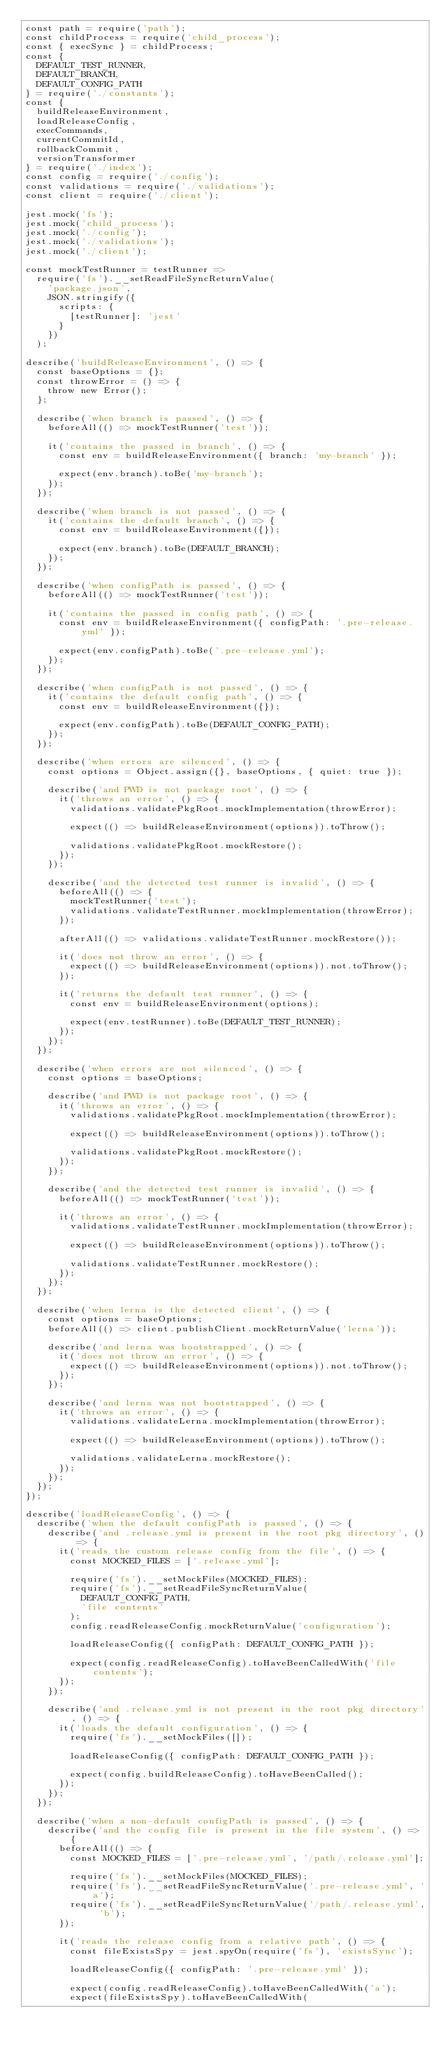<code> <loc_0><loc_0><loc_500><loc_500><_JavaScript_>const path = require('path');
const childProcess = require('child_process');
const { execSync } = childProcess;
const {
  DEFAULT_TEST_RUNNER,
  DEFAULT_BRANCH,
  DEFAULT_CONFIG_PATH
} = require('./constants');
const {
  buildReleaseEnvironment,
  loadReleaseConfig,
  execCommands,
  currentCommitId,
  rollbackCommit,
  versionTransformer
} = require('./index');
const config = require('./config');
const validations = require('./validations');
const client = require('./client');

jest.mock('fs');
jest.mock('child_process');
jest.mock('./config');
jest.mock('./validations');
jest.mock('./client');

const mockTestRunner = testRunner =>
  require('fs').__setReadFileSyncReturnValue(
    'package.json',
    JSON.stringify({
      scripts: {
        [testRunner]: 'jest'
      }
    })
  );

describe('buildReleaseEnvironment', () => {
  const baseOptions = {};
  const throwError = () => {
    throw new Error();
  };

  describe('when branch is passed', () => {
    beforeAll(() => mockTestRunner('test'));

    it('contains the passed in branch', () => {
      const env = buildReleaseEnvironment({ branch: 'my-branch' });

      expect(env.branch).toBe('my-branch');
    });
  });

  describe('when branch is not passed', () => {
    it('contains the default branch', () => {
      const env = buildReleaseEnvironment({});

      expect(env.branch).toBe(DEFAULT_BRANCH);
    });
  });

  describe('when configPath is passed', () => {
    beforeAll(() => mockTestRunner('test'));

    it('contains the passed in config path', () => {
      const env = buildReleaseEnvironment({ configPath: '.pre-release.yml' });

      expect(env.configPath).toBe('.pre-release.yml');
    });
  });

  describe('when configPath is not passed', () => {
    it('contains the default config path', () => {
      const env = buildReleaseEnvironment({});

      expect(env.configPath).toBe(DEFAULT_CONFIG_PATH);
    });
  });

  describe('when errors are silenced', () => {
    const options = Object.assign({}, baseOptions, { quiet: true });

    describe('and PWD is not package root', () => {
      it('throws an error', () => {
        validations.validatePkgRoot.mockImplementation(throwError);

        expect(() => buildReleaseEnvironment(options)).toThrow();

        validations.validatePkgRoot.mockRestore();
      });
    });

    describe('and the detected test runner is invalid', () => {
      beforeAll(() => {
        mockTestRunner('test');
        validations.validateTestRunner.mockImplementation(throwError);
      });

      afterAll(() => validations.validateTestRunner.mockRestore());

      it('does not throw an error', () => {
        expect(() => buildReleaseEnvironment(options)).not.toThrow();
      });

      it('returns the default test runner', () => {
        const env = buildReleaseEnvironment(options);

        expect(env.testRunner).toBe(DEFAULT_TEST_RUNNER);
      });
    });
  });

  describe('when errors are not silenced', () => {
    const options = baseOptions;

    describe('and PWD is not package root', () => {
      it('throws an error', () => {
        validations.validatePkgRoot.mockImplementation(throwError);

        expect(() => buildReleaseEnvironment(options)).toThrow();

        validations.validatePkgRoot.mockRestore();
      });
    });

    describe('and the detected test runner is invalid', () => {
      beforeAll(() => mockTestRunner('test'));

      it('throws an error', () => {
        validations.validateTestRunner.mockImplementation(throwError);

        expect(() => buildReleaseEnvironment(options)).toThrow();

        validations.validateTestRunner.mockRestore();
      });
    });
  });

  describe('when lerna is the detected client', () => {
    const options = baseOptions;
    beforeAll(() => client.publishClient.mockReturnValue('lerna'));

    describe('and lerna was bootstrapped', () => {
      it('does not throw an error', () => {
        expect(() => buildReleaseEnvironment(options)).not.toThrow();
      });
    });

    describe('and lerna was not bootstrapped', () => {
      it('throws an error', () => {
        validations.validateLerna.mockImplementation(throwError);

        expect(() => buildReleaseEnvironment(options)).toThrow();

        validations.validateLerna.mockRestore();
      });
    });
  });
});

describe('loadReleaseConfig', () => {
  describe('when the default configPath is passed', () => {
    describe('and .release.yml is present in the root pkg directory', () => {
      it('reads the custom release config from the file', () => {
        const MOCKED_FILES = ['.release.yml'];

        require('fs').__setMockFiles(MOCKED_FILES);
        require('fs').__setReadFileSyncReturnValue(
          DEFAULT_CONFIG_PATH,
          'file contents'
        );
        config.readReleaseConfig.mockReturnValue('configuration');

        loadReleaseConfig({ configPath: DEFAULT_CONFIG_PATH });

        expect(config.readReleaseConfig).toHaveBeenCalledWith('file contents');
      });
    });

    describe('and .release.yml is not present in the root pkg directory', () => {
      it('loads the default configuration', () => {
        require('fs').__setMockFiles([]);

        loadReleaseConfig({ configPath: DEFAULT_CONFIG_PATH });

        expect(config.buildReleaseConfig).toHaveBeenCalled();
      });
    });
  });

  describe('when a non-default configPath is passed', () => {
    describe('and the config file is present in the file system', () => {
      beforeAll(() => {
        const MOCKED_FILES = ['.pre-release.yml', '/path/.release.yml'];

        require('fs').__setMockFiles(MOCKED_FILES);
        require('fs').__setReadFileSyncReturnValue('.pre-release.yml', 'a');
        require('fs').__setReadFileSyncReturnValue('/path/.release.yml', 'b');
      });

      it('reads the release config from a relative path', () => {
        const fileExistsSpy = jest.spyOn(require('fs'), 'existsSync');

        loadReleaseConfig({ configPath: '.pre-release.yml' });

        expect(config.readReleaseConfig).toHaveBeenCalledWith('a');
        expect(fileExistsSpy).toHaveBeenCalledWith(</code> 